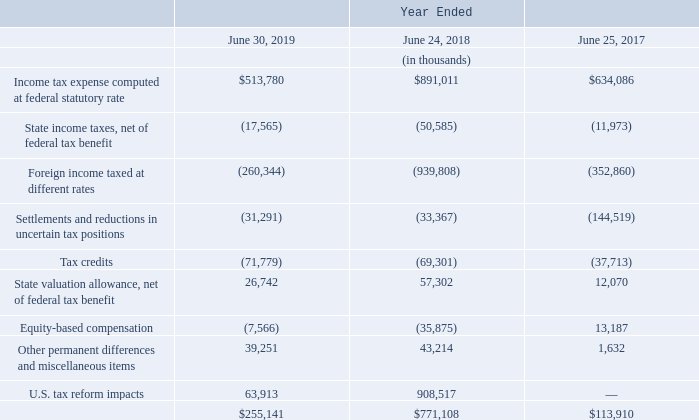A reconciliation of income tax expense provided at the federal statutory rate (21% in fiscal year 2019, 28.27% in fiscal year 2018, and 35% in fiscal year 2017) to actual income tax expense is as follows:
In July 2015, the U.S. Tax Court issued an opinion favorable to Altera with respect to Altera’s litigation with the IRS. The litigation related to the treatment of stock-based compensation expense in an intercompany cost-sharing arrangement with Altera’s foreign subsidiary. In its opinion, the U.S. Tax Court accepted Altera’s position of excluding stock-based compensation from its intercompany cost-sharing arrangement. In June 2019, the Ninth Circuit, through a three-judge panel, reversed the 2015 decision of the U.S. Tax Court. Altera has petitioned the Ninth Circuit for an en banc rehearing of a larger panel of eleven Ninth Circuit judges. The Company will continue to monitor and evaluate the potential impact of this litigation on its fiscal year 2020 Consolidated Financial Statements. The estimated potential impact is in the range of $75 million, which may result in a decrease in deferred tax assets and an increase in tax expense.
Effective from fiscal year 2014 through 2017, the Company had a tax ruling in Switzerland for one of its foreign subsidiaries. The impact of the tax ruling decreased taxes by approximately $6.3 million for fiscal year 2017. The benefit of the tax ruling on diluted earnings per share was approximately $0.03 in fiscal year 2017. Effective fiscal year 2018, the Company has withdrawn its reduced tax rate ruling in Switzerland for this subsidiary due to the ruling being no longer necessary as the subsidiary meets the requirements to achieve the reduced tax rate under Swiss tax law.
Earnings of the Company’s foreign subsidiaries included in consolidated retained earnings that are indefinitely reinvested in foreign operations aggregated to approximately $458.4 million at June 30, 2019. If these earnings were remitted to the United States, they would be subject to foreign withholding taxes of approximately $73.1 million at current statutory rates.
What might the estimated potential impact being in the range of $75 million result in? A decrease in deferred tax assets and an increase in tax expense. What was the impact of tax ruling on taxes? Decreased taxes by approximately $6.3 million for fiscal year 2017. What is the amount of foreign withholding taxes at current statutory rates? $73.1 million. What is the percentage change in the Income tax expense computed at federal statutory rate from 2018 to 2019?
Answer scale should be: percent. (513,780-891,011)/891,011
Answer: -42.34. What is the percentage change in the Other permanent differences and miscellaneous items from 2018 to 2019?
Answer scale should be: percent. (39,251-43,214)/43,214
Answer: -9.17. In which year is the actual income tax expense the highest? Find the year with the highest actual income tax expense
Answer: 2018. 